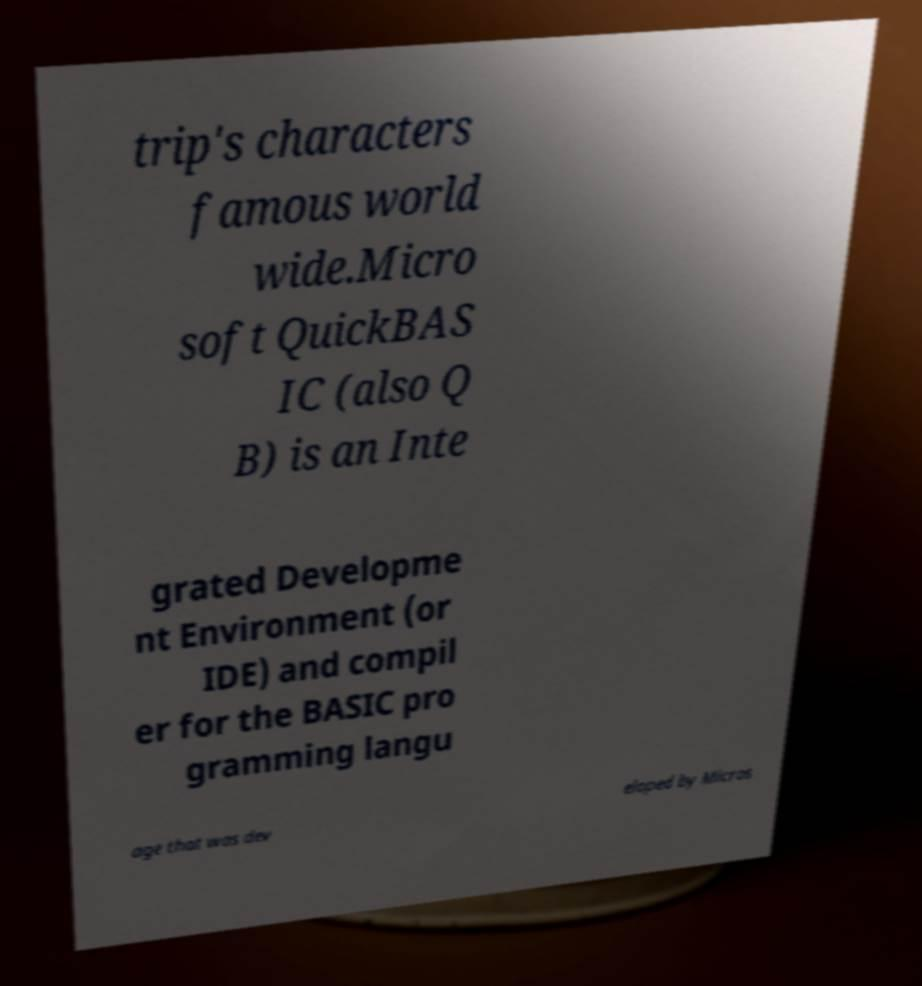For documentation purposes, I need the text within this image transcribed. Could you provide that? trip's characters famous world wide.Micro soft QuickBAS IC (also Q B) is an Inte grated Developme nt Environment (or IDE) and compil er for the BASIC pro gramming langu age that was dev eloped by Micros 